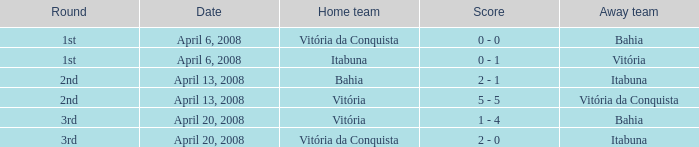Would you mind parsing the complete table? {'header': ['Round', 'Date', 'Home team', 'Score', 'Away team'], 'rows': [['1st', 'April 6, 2008', 'Vitória da Conquista', '0 - 0', 'Bahia'], ['1st', 'April 6, 2008', 'Itabuna', '0 - 1', 'Vitória'], ['2nd', 'April 13, 2008', 'Bahia', '2 - 1', 'Itabuna'], ['2nd', 'April 13, 2008', 'Vitória', '5 - 5', 'Vitória da Conquista'], ['3rd', 'April 20, 2008', 'Vitória', '1 - 4', 'Bahia'], ['3rd', 'April 20, 2008', 'Vitória da Conquista', '2 - 0', 'Itabuna']]} When vitória was the visiting team, who was the host team? Itabuna. 